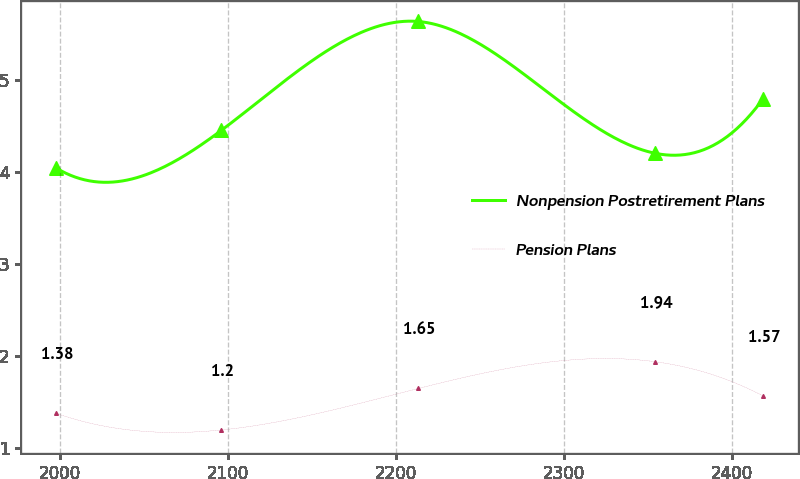Convert chart to OTSL. <chart><loc_0><loc_0><loc_500><loc_500><line_chart><ecel><fcel>Nonpension Postretirement Plans<fcel>Pension Plans<nl><fcel>1997.7<fcel>4.04<fcel>1.38<nl><fcel>2096.03<fcel>4.45<fcel>1.2<nl><fcel>2213.19<fcel>5.63<fcel>1.65<nl><fcel>2354.36<fcel>4.2<fcel>1.94<nl><fcel>2418.35<fcel>4.79<fcel>1.57<nl></chart> 